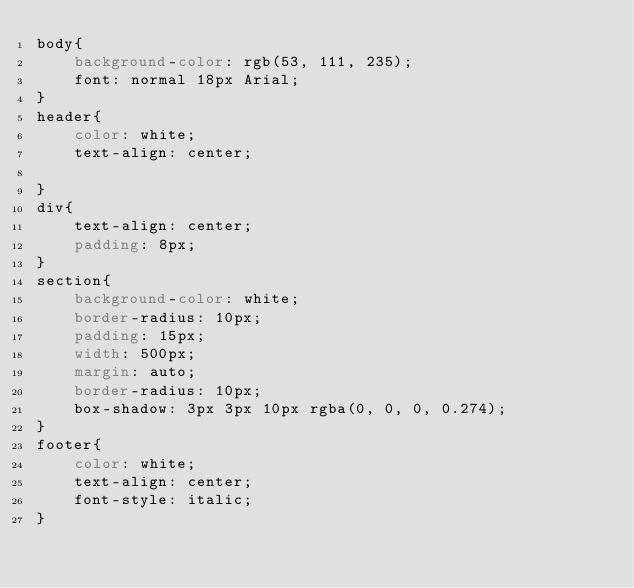<code> <loc_0><loc_0><loc_500><loc_500><_CSS_>body{
    background-color: rgb(53, 111, 235);
    font: normal 18px Arial;
}
header{
    color: white;
    text-align: center;

}
div{
    text-align: center;
    padding: 8px;
}
section{
    background-color: white;
    border-radius: 10px;
    padding: 15px;
    width: 500px;
    margin: auto;
    border-radius: 10px;
    box-shadow: 3px 3px 10px rgba(0, 0, 0, 0.274);
}
footer{
    color: white;
    text-align: center;
    font-style: italic;
}</code> 